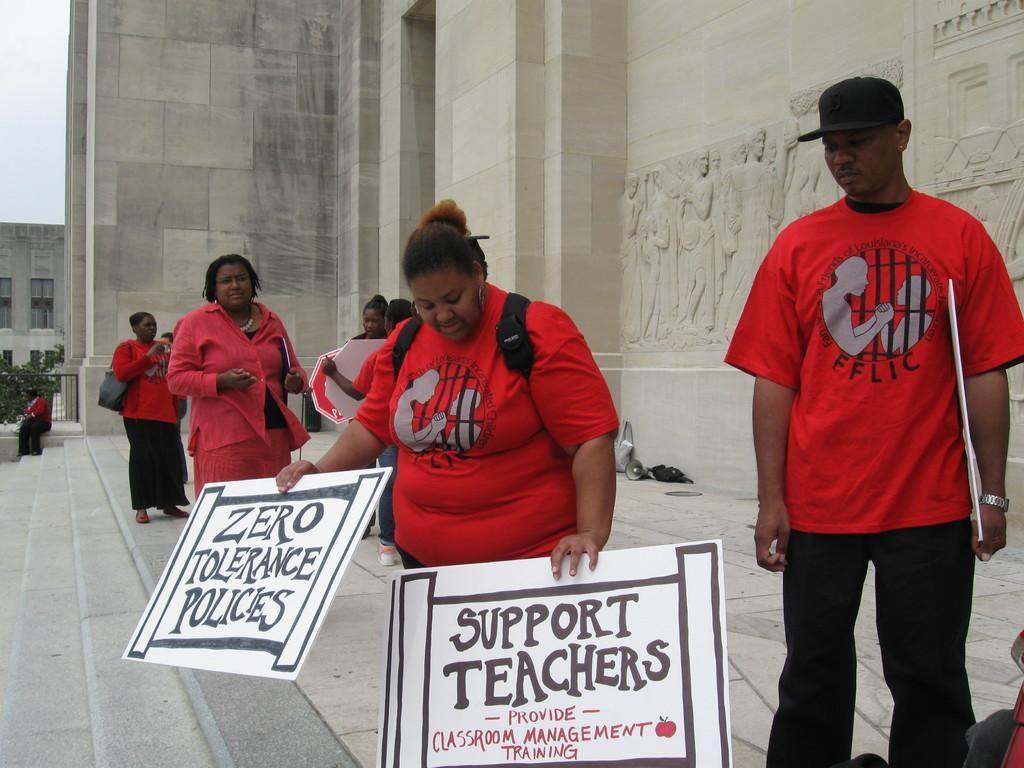What is the woman in the image holding? The woman is holding boards in the image. Are there any other people present in the image? Yes, people are standing near the boards. What can be seen in the background of the image? There is a building and the sky visible in the image. How many kittens are sitting on the boards in the image? There are no kittens present in the image; it only features a woman holding boards and people standing near them. 